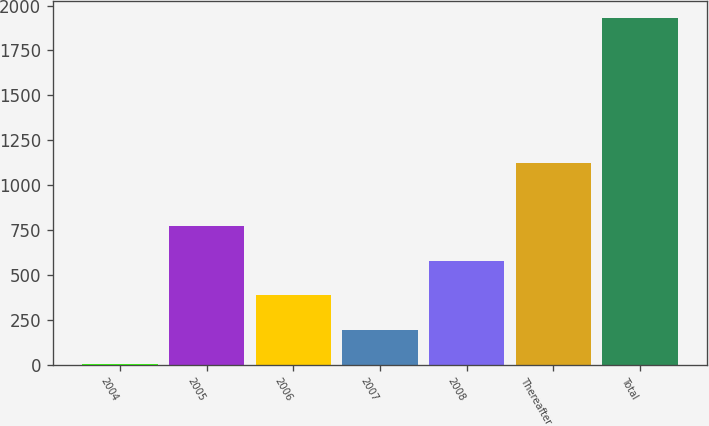Convert chart. <chart><loc_0><loc_0><loc_500><loc_500><bar_chart><fcel>2004<fcel>2005<fcel>2006<fcel>2007<fcel>2008<fcel>Thereafter<fcel>Total<nl><fcel>1<fcel>772.6<fcel>386.8<fcel>193.9<fcel>579.7<fcel>1122<fcel>1930<nl></chart> 